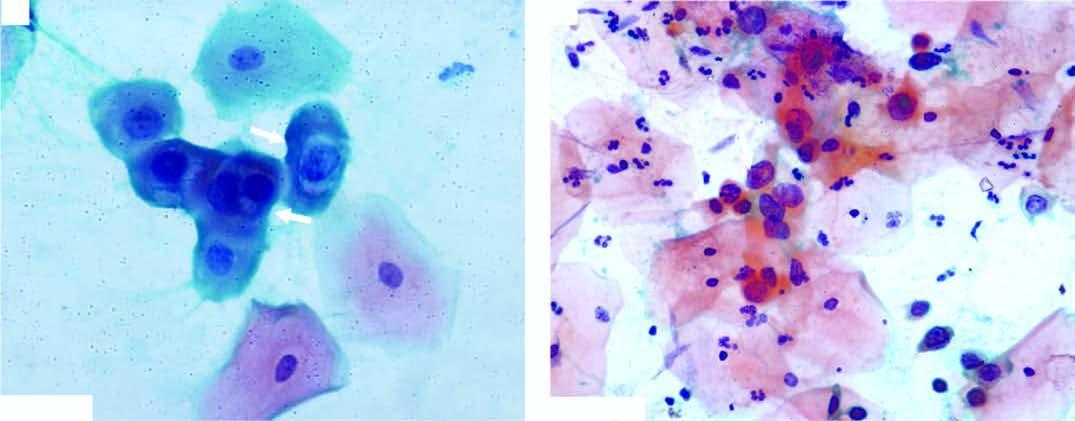do lassification of chromosomes have scanty cytoplasm and markedly hyperchromatic nuclei having irregular nuclear outlines?
Answer the question using a single word or phrase. No 